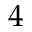Convert formula to latex. <formula><loc_0><loc_0><loc_500><loc_500>4</formula> 